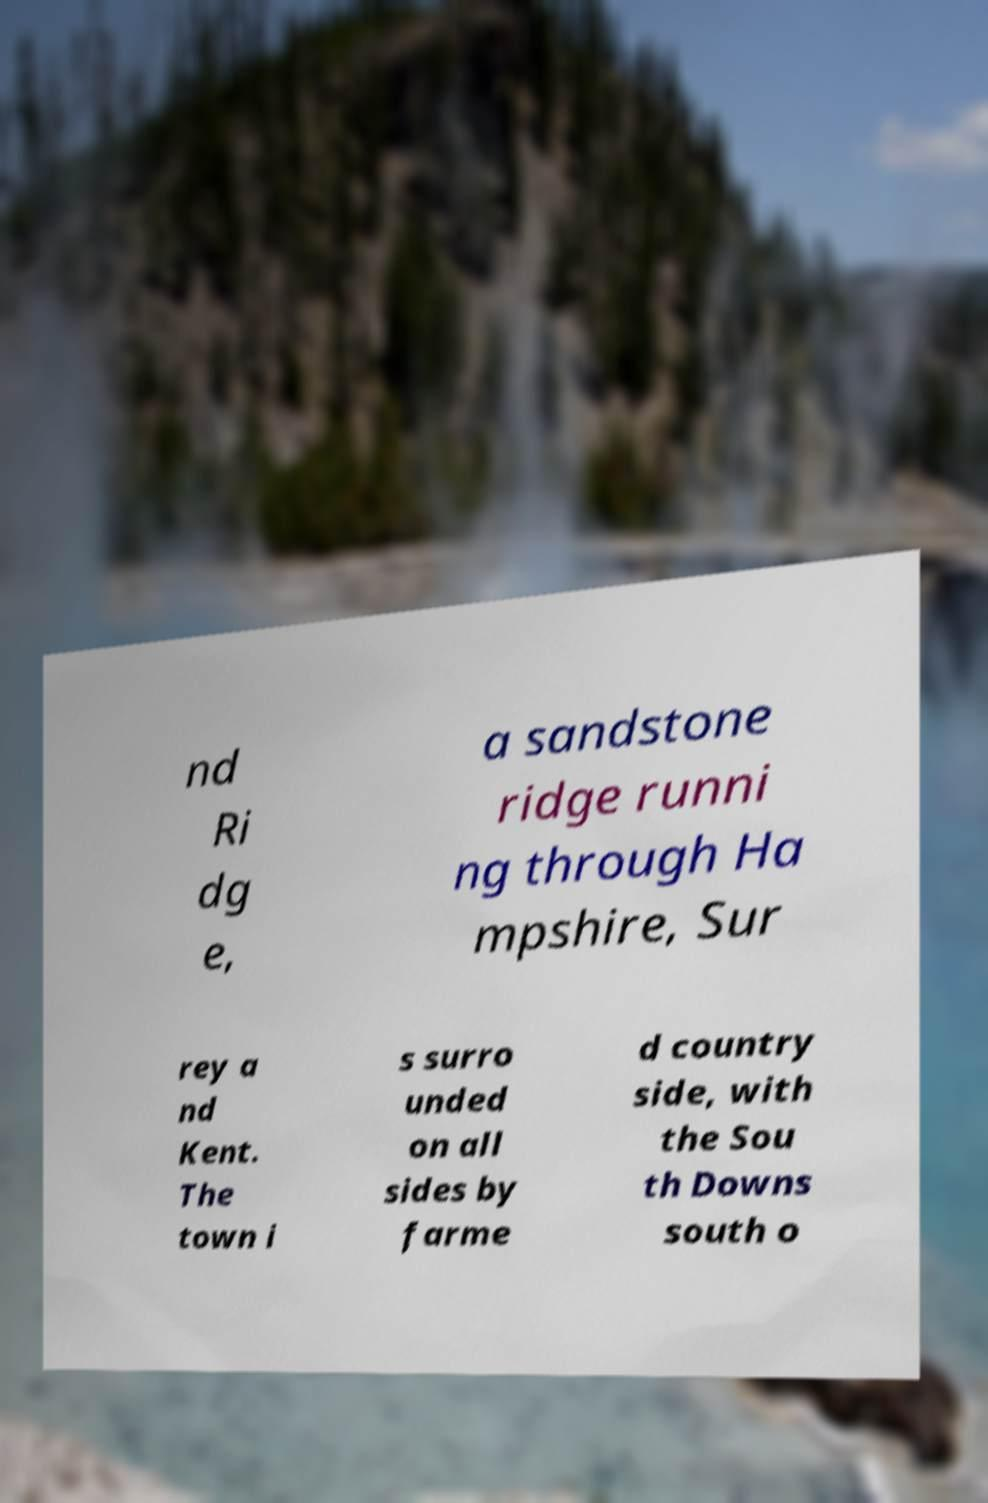Can you read and provide the text displayed in the image?This photo seems to have some interesting text. Can you extract and type it out for me? nd Ri dg e, a sandstone ridge runni ng through Ha mpshire, Sur rey a nd Kent. The town i s surro unded on all sides by farme d country side, with the Sou th Downs south o 